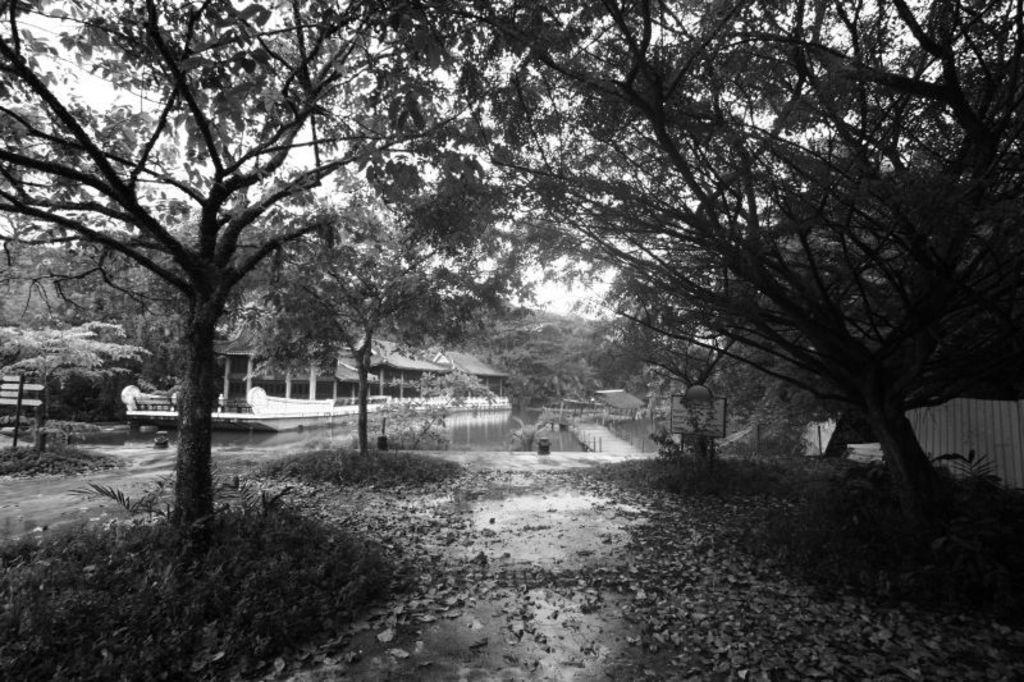Describe this image in one or two sentences. This is a black and white picture. At the bottom, we see the road, dry leaves and the shrubs. We see the trees. On the left side, we see a pole and the trees. In the middle, we see water and this water might be in the pond. There are trees and a building in the background. On the right side, we see the trees and a thing which looks like a wall. 